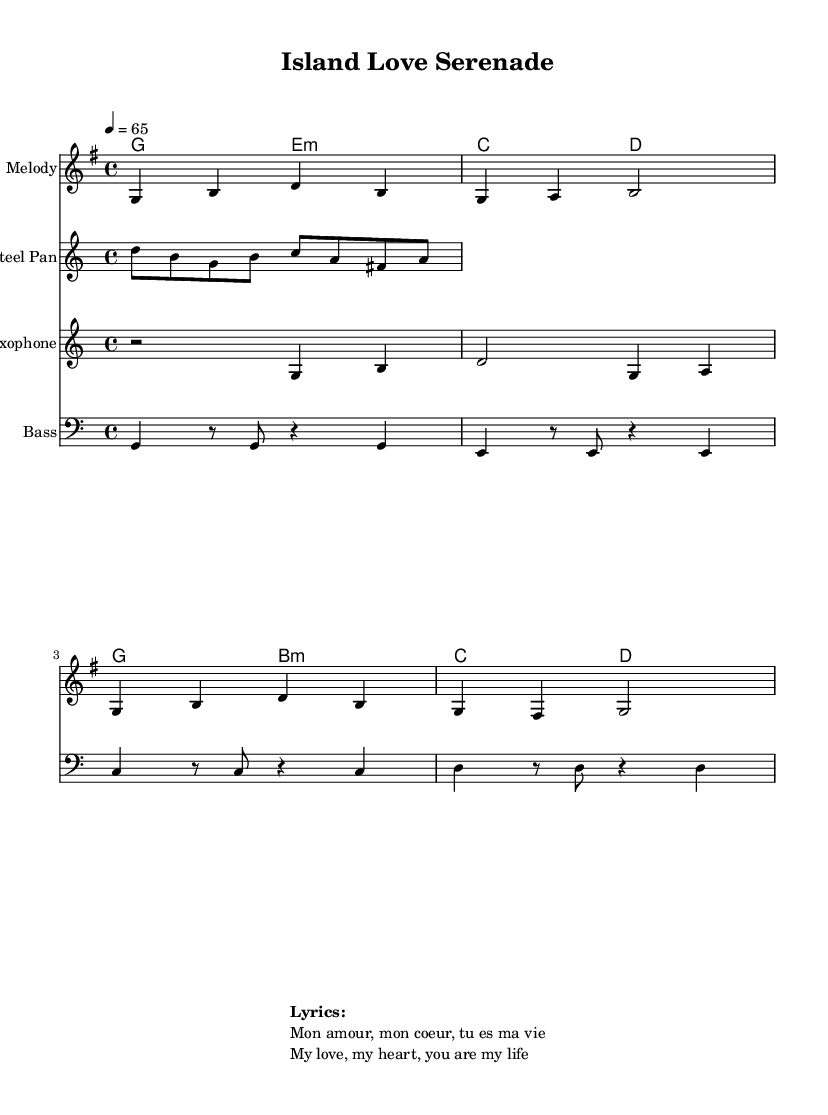What is the key signature of this music? The key signature is G major, which has one sharp (F#). This is indicated at the beginning of the music sheet where the key signature is displayed.
Answer: G major What is the time signature of this music? The time signature is 4/4, which means there are four beats in each measure and the quarter note gets one beat. This is shown at the start of the piece, directly following the key signature.
Answer: 4/4 What is the tempo marking for this music? The tempo marking indicates a speed of 65 beats per minute. This is shown where it states "4 = 65" under the global definitions.
Answer: 65 How many measures are in the melody section? The melody section consists of four measures. This can be counted by looking at the vertical bar lines, which indicate the end of each measure.
Answer: 4 What instrument is playing the melody in this piece? The melody is assigned to the staff labeled "Melody." This is indicated at the beginning of the staff section.
Answer: Melody What lyrics accompany this music? The lyrics provided are "Mon amour, mon coeur, tu es ma vie," which translates to "My love, my heart, you are my life." This is written in the markup section below the music.
Answer: Mon amour, mon coeur, tu es ma vie What characteristic makes this music romantic in style? The romantic style is characterized by its slow tempo, gentle melodic lines, and expressive harmonies that evoke feelings of love. The overall structure and lyrics contribute to the romantic theme.
Answer: Slow tempo 